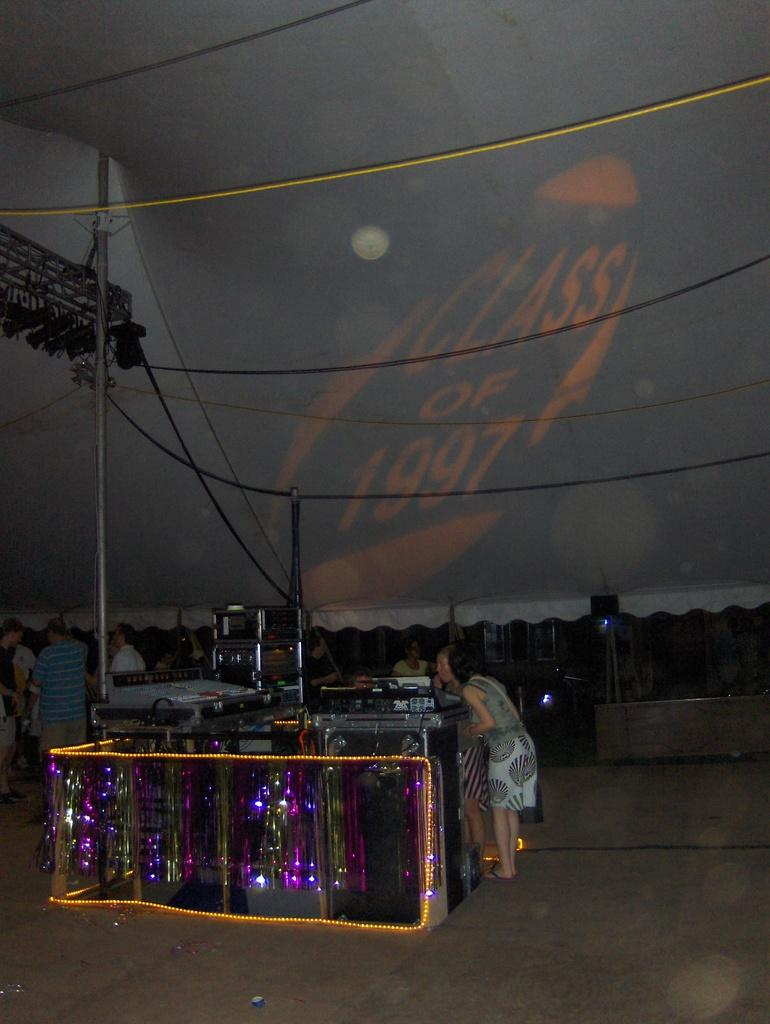What are the people in the image doing? The people in the image are standing under a tent. What can be seen around the people? There are objects decorated with lights around the people. What is the purpose of the pole in the image? The pole is likely used to support the tent. What is the purpose of the rope in the image? The rope might be used to secure or stabilize the tent or the objects decorated with lights. What is written or displayed on the tent? There is text over the tent. What type of thread is used to sew the shoes in the image? There are no shoes present in the image, so it is not possible to determine the type of thread used to sew them. 